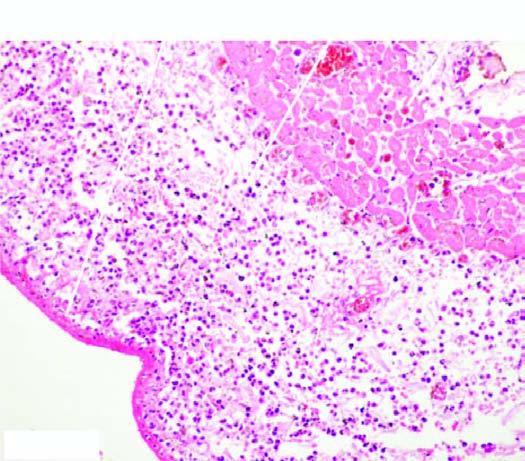s the pericardium covered with pink serofibrinous exudates?
Answer the question using a single word or phrase. Yes 